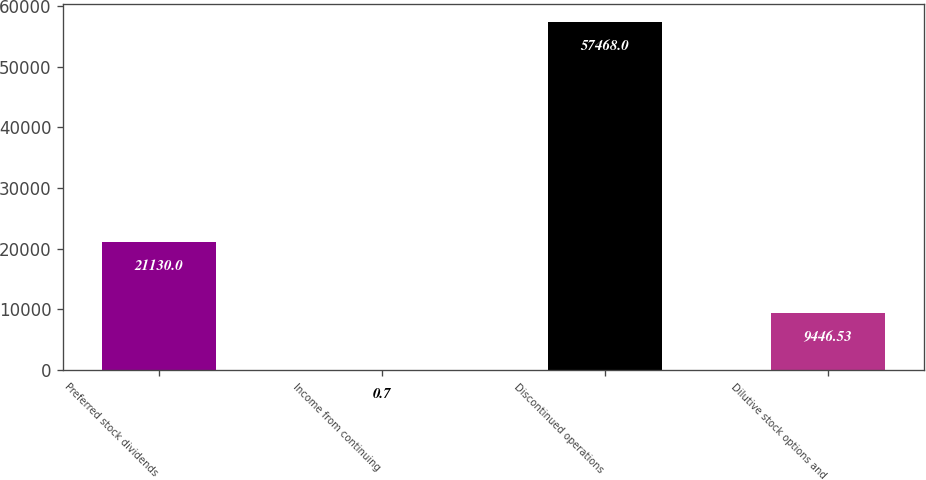<chart> <loc_0><loc_0><loc_500><loc_500><bar_chart><fcel>Preferred stock dividends<fcel>Income from continuing<fcel>Discontinued operations<fcel>Dilutive stock options and<nl><fcel>21130<fcel>0.7<fcel>57468<fcel>9446.53<nl></chart> 